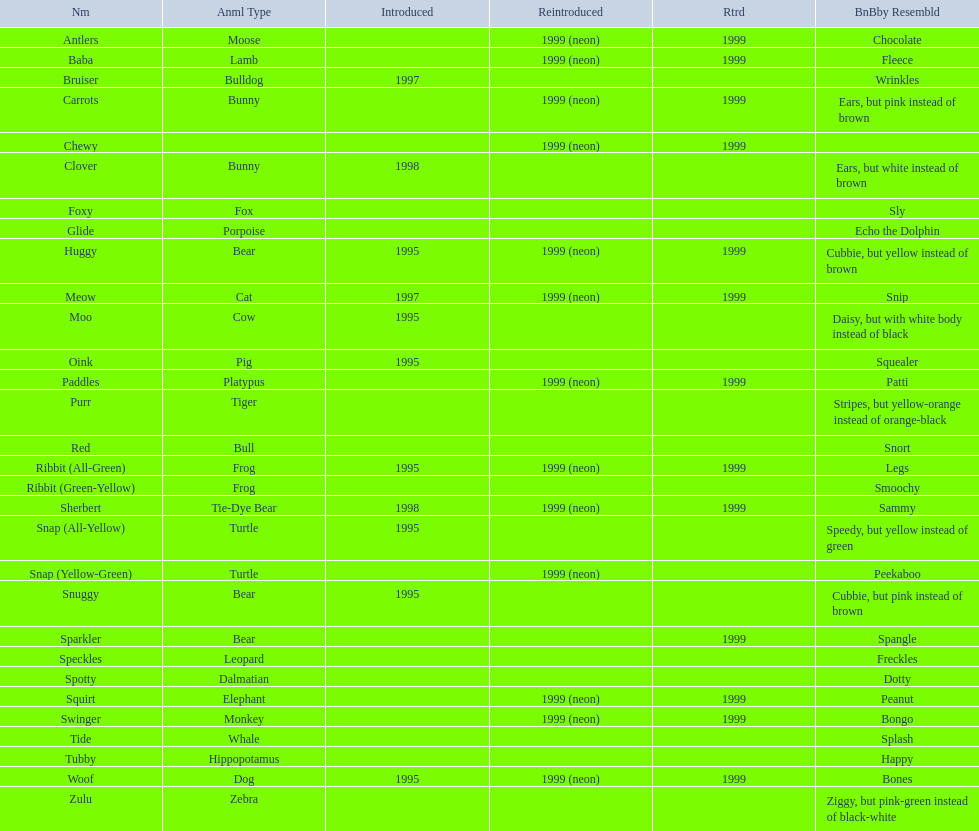What animals are pillow pals? Moose, Lamb, Bulldog, Bunny, Bunny, Fox, Porpoise, Bear, Cat, Cow, Pig, Platypus, Tiger, Bull, Frog, Frog, Tie-Dye Bear, Turtle, Turtle, Bear, Bear, Leopard, Dalmatian, Elephant, Monkey, Whale, Hippopotamus, Dog, Zebra. What is the name of the dalmatian? Spotty. 